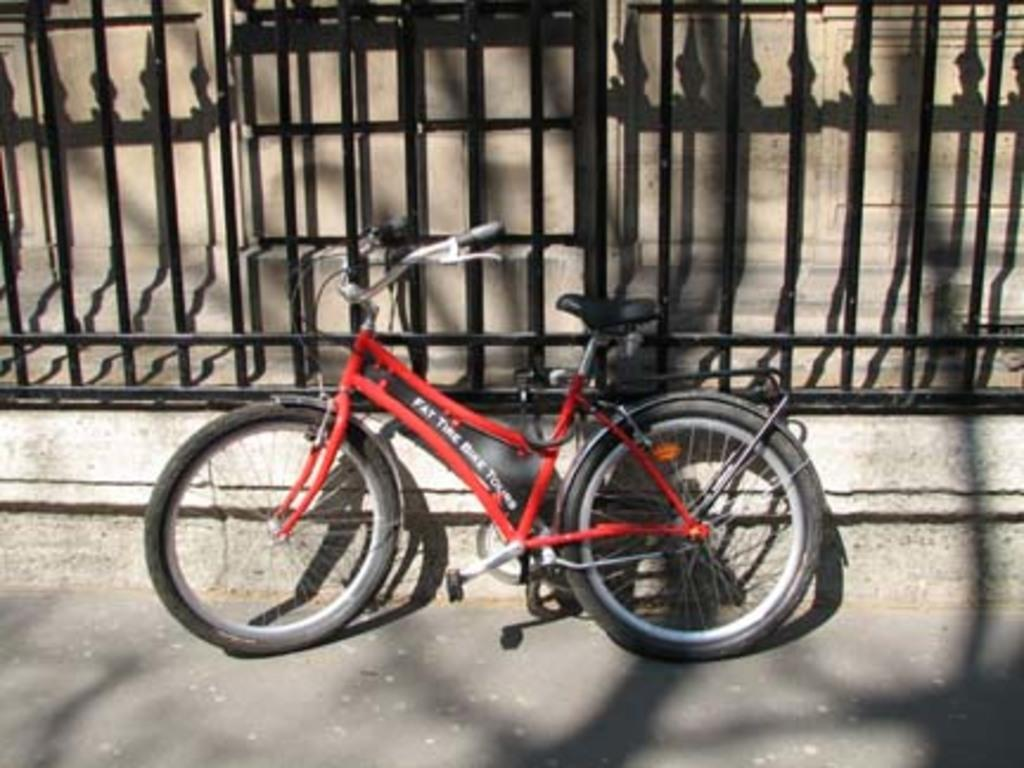What is in the foreground of the image? There is a road in the foreground of the image. What can be seen in the center of the image? There is a bicycle in the center of the image. What type of structure is present in the image? There are railings and a wall in the image. Can you see an umbrella being used as a weapon in the image? There is no umbrella or any weapon present in the image. What type of rod is being used to control the bicycle in the image? There is no rod or any device used to control the bicycle in the image; it appears to be a regular bicycle. 